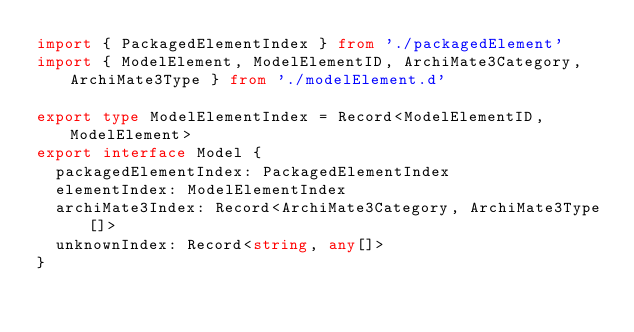<code> <loc_0><loc_0><loc_500><loc_500><_TypeScript_>import { PackagedElementIndex } from './packagedElement'
import { ModelElement, ModelElementID, ArchiMate3Category, ArchiMate3Type } from './modelElement.d'

export type ModelElementIndex = Record<ModelElementID, ModelElement>
export interface Model {
  packagedElementIndex: PackagedElementIndex
  elementIndex: ModelElementIndex
  archiMate3Index: Record<ArchiMate3Category, ArchiMate3Type[]>
  unknownIndex: Record<string, any[]>
}
</code> 